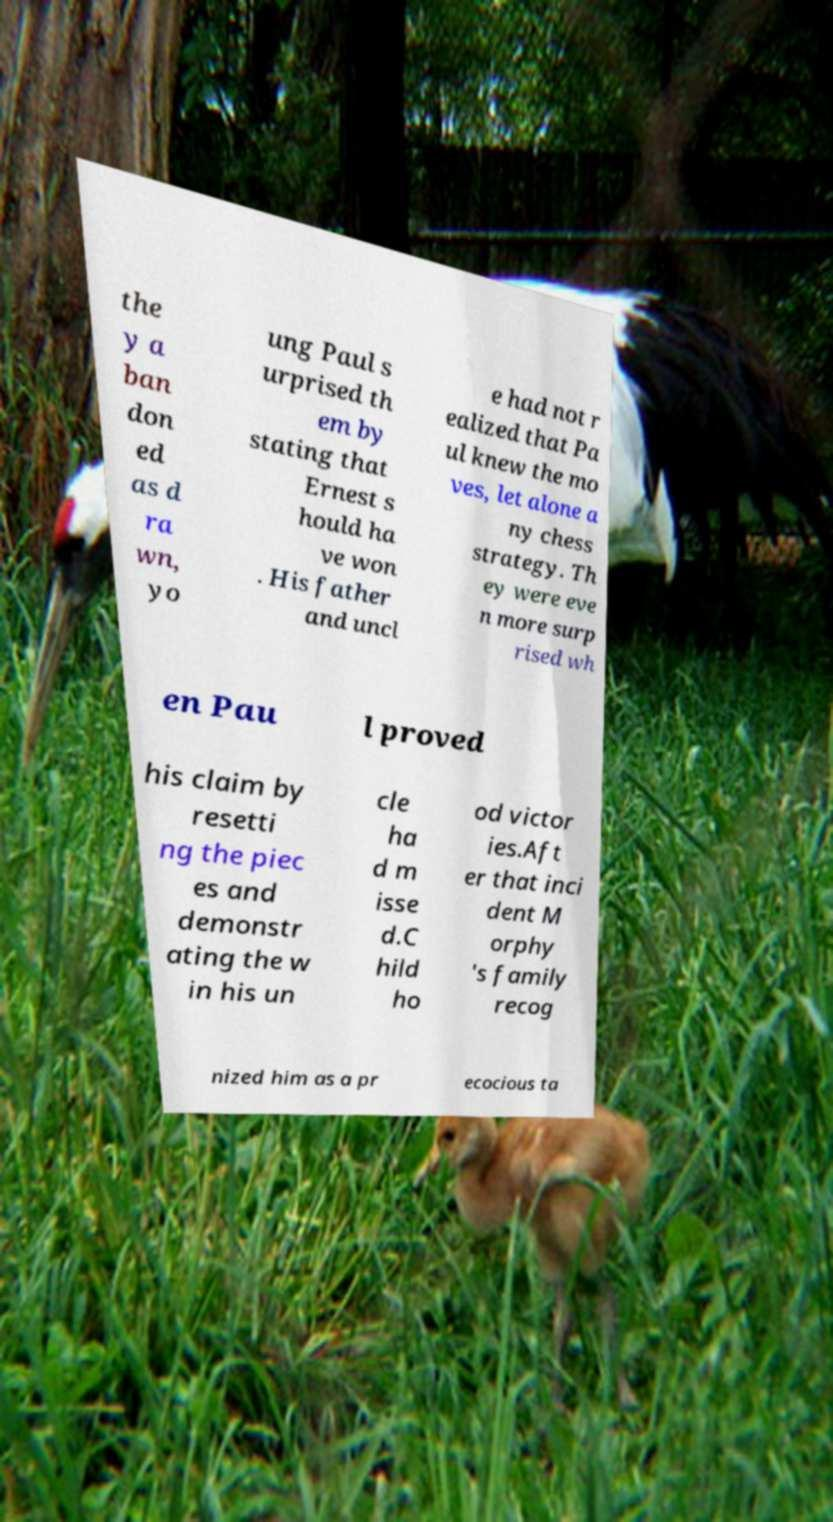Please identify and transcribe the text found in this image. the y a ban don ed as d ra wn, yo ung Paul s urprised th em by stating that Ernest s hould ha ve won . His father and uncl e had not r ealized that Pa ul knew the mo ves, let alone a ny chess strategy. Th ey were eve n more surp rised wh en Pau l proved his claim by resetti ng the piec es and demonstr ating the w in his un cle ha d m isse d.C hild ho od victor ies.Aft er that inci dent M orphy 's family recog nized him as a pr ecocious ta 